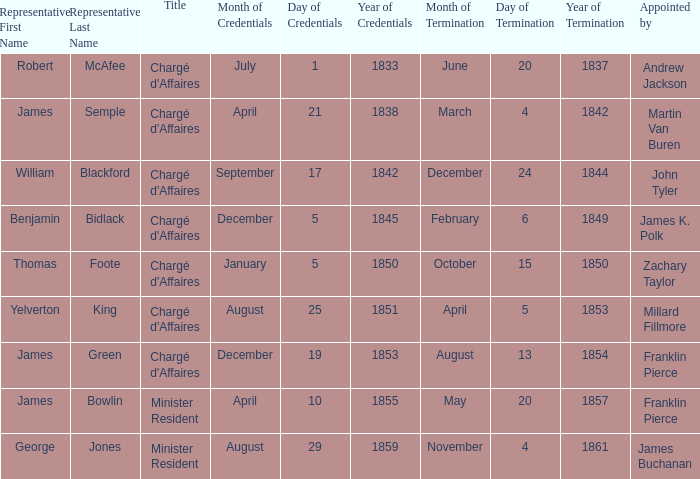What Title has a Termination of Mission for August 13, 1854? Chargé d'Affaires. 